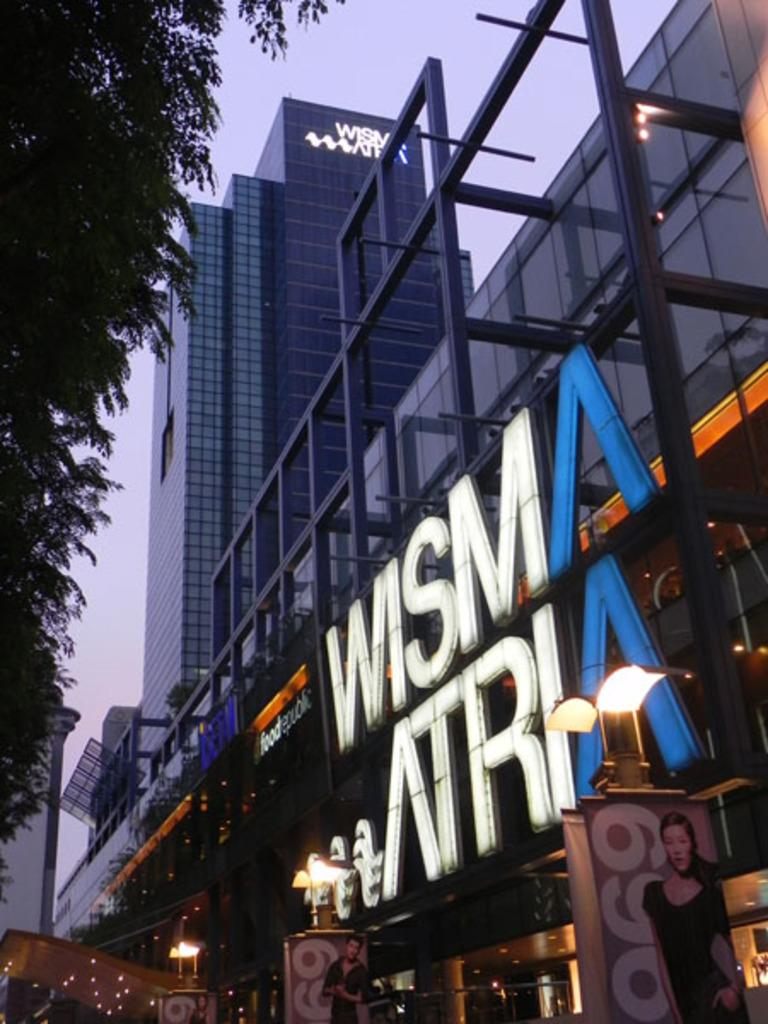What type of structures can be seen in the image? There are buildings in the image. What natural elements are present in the image? There are trees in the image. What artificial elements are present in the image? There are lights and led boards in the image. What other objects can be seen in the image? There are other objects in the image, but their specific details are not mentioned in the facts. What can be seen in the background of the image? The sky is visible in the background of the image. How does the oven affect the friction in the image? There is no oven present in the image, so it cannot affect the friction. What date is marked on the calendar in the image? There is no calendar present in the image, so it is not possible to determine the date. 